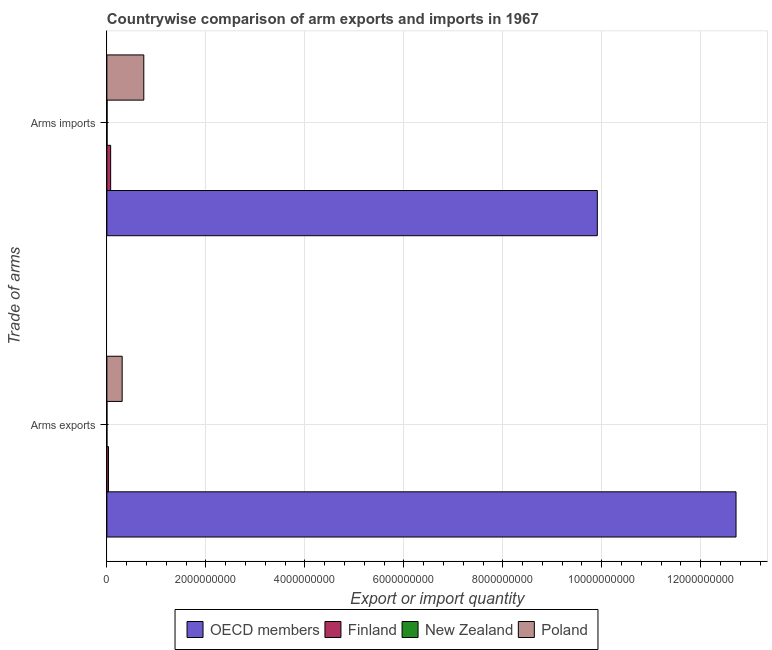Are the number of bars per tick equal to the number of legend labels?
Your response must be concise. Yes. Are the number of bars on each tick of the Y-axis equal?
Your answer should be very brief. Yes. How many bars are there on the 2nd tick from the top?
Provide a succinct answer. 4. How many bars are there on the 2nd tick from the bottom?
Offer a terse response. 4. What is the label of the 2nd group of bars from the top?
Keep it short and to the point. Arms exports. What is the arms exports in Poland?
Ensure brevity in your answer.  3.09e+08. Across all countries, what is the maximum arms imports?
Provide a short and direct response. 9.91e+09. Across all countries, what is the minimum arms exports?
Provide a succinct answer. 1.00e+06. In which country was the arms exports minimum?
Offer a very short reply. New Zealand. What is the total arms exports in the graph?
Offer a terse response. 1.31e+1. What is the difference between the arms exports in Finland and that in OECD members?
Make the answer very short. -1.27e+1. What is the difference between the arms imports in New Zealand and the arms exports in OECD members?
Provide a succinct answer. -1.27e+1. What is the average arms exports per country?
Offer a terse response. 3.26e+09. What is the difference between the arms exports and arms imports in OECD members?
Your answer should be compact. 2.80e+09. What is the ratio of the arms exports in Finland to that in New Zealand?
Keep it short and to the point. 33. What does the 2nd bar from the top in Arms exports represents?
Give a very brief answer. New Zealand. What does the 2nd bar from the bottom in Arms exports represents?
Make the answer very short. Finland. How many bars are there?
Ensure brevity in your answer.  8. How many countries are there in the graph?
Provide a succinct answer. 4. Are the values on the major ticks of X-axis written in scientific E-notation?
Your answer should be compact. No. Does the graph contain grids?
Offer a very short reply. Yes. Where does the legend appear in the graph?
Provide a short and direct response. Bottom center. How many legend labels are there?
Your answer should be compact. 4. How are the legend labels stacked?
Keep it short and to the point. Horizontal. What is the title of the graph?
Provide a short and direct response. Countrywise comparison of arm exports and imports in 1967. What is the label or title of the X-axis?
Make the answer very short. Export or import quantity. What is the label or title of the Y-axis?
Keep it short and to the point. Trade of arms. What is the Export or import quantity of OECD members in Arms exports?
Offer a terse response. 1.27e+1. What is the Export or import quantity in Finland in Arms exports?
Ensure brevity in your answer.  3.30e+07. What is the Export or import quantity in New Zealand in Arms exports?
Provide a short and direct response. 1.00e+06. What is the Export or import quantity of Poland in Arms exports?
Provide a succinct answer. 3.09e+08. What is the Export or import quantity of OECD members in Arms imports?
Your answer should be very brief. 9.91e+09. What is the Export or import quantity of Finland in Arms imports?
Your response must be concise. 7.60e+07. What is the Export or import quantity of Poland in Arms imports?
Make the answer very short. 7.46e+08. Across all Trade of arms, what is the maximum Export or import quantity in OECD members?
Your answer should be compact. 1.27e+1. Across all Trade of arms, what is the maximum Export or import quantity in Finland?
Ensure brevity in your answer.  7.60e+07. Across all Trade of arms, what is the maximum Export or import quantity in New Zealand?
Make the answer very short. 4.00e+06. Across all Trade of arms, what is the maximum Export or import quantity in Poland?
Offer a very short reply. 7.46e+08. Across all Trade of arms, what is the minimum Export or import quantity of OECD members?
Ensure brevity in your answer.  9.91e+09. Across all Trade of arms, what is the minimum Export or import quantity of Finland?
Keep it short and to the point. 3.30e+07. Across all Trade of arms, what is the minimum Export or import quantity of Poland?
Your answer should be compact. 3.09e+08. What is the total Export or import quantity in OECD members in the graph?
Provide a succinct answer. 2.26e+1. What is the total Export or import quantity of Finland in the graph?
Offer a terse response. 1.09e+08. What is the total Export or import quantity of New Zealand in the graph?
Provide a short and direct response. 5.00e+06. What is the total Export or import quantity in Poland in the graph?
Make the answer very short. 1.06e+09. What is the difference between the Export or import quantity of OECD members in Arms exports and that in Arms imports?
Offer a terse response. 2.80e+09. What is the difference between the Export or import quantity in Finland in Arms exports and that in Arms imports?
Make the answer very short. -4.30e+07. What is the difference between the Export or import quantity of New Zealand in Arms exports and that in Arms imports?
Offer a terse response. -3.00e+06. What is the difference between the Export or import quantity of Poland in Arms exports and that in Arms imports?
Provide a short and direct response. -4.37e+08. What is the difference between the Export or import quantity of OECD members in Arms exports and the Export or import quantity of Finland in Arms imports?
Ensure brevity in your answer.  1.26e+1. What is the difference between the Export or import quantity in OECD members in Arms exports and the Export or import quantity in New Zealand in Arms imports?
Your response must be concise. 1.27e+1. What is the difference between the Export or import quantity of OECD members in Arms exports and the Export or import quantity of Poland in Arms imports?
Give a very brief answer. 1.20e+1. What is the difference between the Export or import quantity of Finland in Arms exports and the Export or import quantity of New Zealand in Arms imports?
Give a very brief answer. 2.90e+07. What is the difference between the Export or import quantity in Finland in Arms exports and the Export or import quantity in Poland in Arms imports?
Your response must be concise. -7.13e+08. What is the difference between the Export or import quantity in New Zealand in Arms exports and the Export or import quantity in Poland in Arms imports?
Provide a short and direct response. -7.45e+08. What is the average Export or import quantity in OECD members per Trade of arms?
Keep it short and to the point. 1.13e+1. What is the average Export or import quantity in Finland per Trade of arms?
Give a very brief answer. 5.45e+07. What is the average Export or import quantity of New Zealand per Trade of arms?
Your answer should be very brief. 2.50e+06. What is the average Export or import quantity of Poland per Trade of arms?
Your answer should be very brief. 5.28e+08. What is the difference between the Export or import quantity in OECD members and Export or import quantity in Finland in Arms exports?
Give a very brief answer. 1.27e+1. What is the difference between the Export or import quantity in OECD members and Export or import quantity in New Zealand in Arms exports?
Offer a terse response. 1.27e+1. What is the difference between the Export or import quantity in OECD members and Export or import quantity in Poland in Arms exports?
Offer a very short reply. 1.24e+1. What is the difference between the Export or import quantity in Finland and Export or import quantity in New Zealand in Arms exports?
Provide a short and direct response. 3.20e+07. What is the difference between the Export or import quantity of Finland and Export or import quantity of Poland in Arms exports?
Give a very brief answer. -2.76e+08. What is the difference between the Export or import quantity of New Zealand and Export or import quantity of Poland in Arms exports?
Your response must be concise. -3.08e+08. What is the difference between the Export or import quantity in OECD members and Export or import quantity in Finland in Arms imports?
Your answer should be compact. 9.83e+09. What is the difference between the Export or import quantity of OECD members and Export or import quantity of New Zealand in Arms imports?
Offer a terse response. 9.91e+09. What is the difference between the Export or import quantity of OECD members and Export or import quantity of Poland in Arms imports?
Your response must be concise. 9.16e+09. What is the difference between the Export or import quantity of Finland and Export or import quantity of New Zealand in Arms imports?
Give a very brief answer. 7.20e+07. What is the difference between the Export or import quantity of Finland and Export or import quantity of Poland in Arms imports?
Provide a short and direct response. -6.70e+08. What is the difference between the Export or import quantity of New Zealand and Export or import quantity of Poland in Arms imports?
Provide a short and direct response. -7.42e+08. What is the ratio of the Export or import quantity of OECD members in Arms exports to that in Arms imports?
Ensure brevity in your answer.  1.28. What is the ratio of the Export or import quantity of Finland in Arms exports to that in Arms imports?
Make the answer very short. 0.43. What is the ratio of the Export or import quantity in Poland in Arms exports to that in Arms imports?
Your answer should be compact. 0.41. What is the difference between the highest and the second highest Export or import quantity in OECD members?
Offer a terse response. 2.80e+09. What is the difference between the highest and the second highest Export or import quantity in Finland?
Your response must be concise. 4.30e+07. What is the difference between the highest and the second highest Export or import quantity in Poland?
Give a very brief answer. 4.37e+08. What is the difference between the highest and the lowest Export or import quantity in OECD members?
Provide a succinct answer. 2.80e+09. What is the difference between the highest and the lowest Export or import quantity of Finland?
Your response must be concise. 4.30e+07. What is the difference between the highest and the lowest Export or import quantity in New Zealand?
Ensure brevity in your answer.  3.00e+06. What is the difference between the highest and the lowest Export or import quantity in Poland?
Provide a succinct answer. 4.37e+08. 